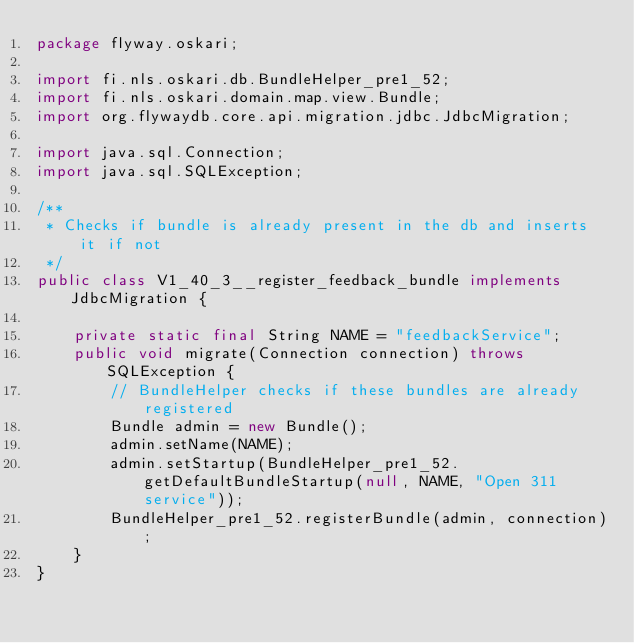Convert code to text. <code><loc_0><loc_0><loc_500><loc_500><_Java_>package flyway.oskari;

import fi.nls.oskari.db.BundleHelper_pre1_52;
import fi.nls.oskari.domain.map.view.Bundle;
import org.flywaydb.core.api.migration.jdbc.JdbcMigration;

import java.sql.Connection;
import java.sql.SQLException;

/**
 * Checks if bundle is already present in the db and inserts it if not
 */
public class V1_40_3__register_feedback_bundle implements JdbcMigration {

    private static final String NAME = "feedbackService";
    public void migrate(Connection connection) throws SQLException {
        // BundleHelper checks if these bundles are already registered
        Bundle admin = new Bundle();
        admin.setName(NAME);
        admin.setStartup(BundleHelper_pre1_52.getDefaultBundleStartup(null, NAME, "Open 311 service"));
        BundleHelper_pre1_52.registerBundle(admin, connection);
    }
}
</code> 